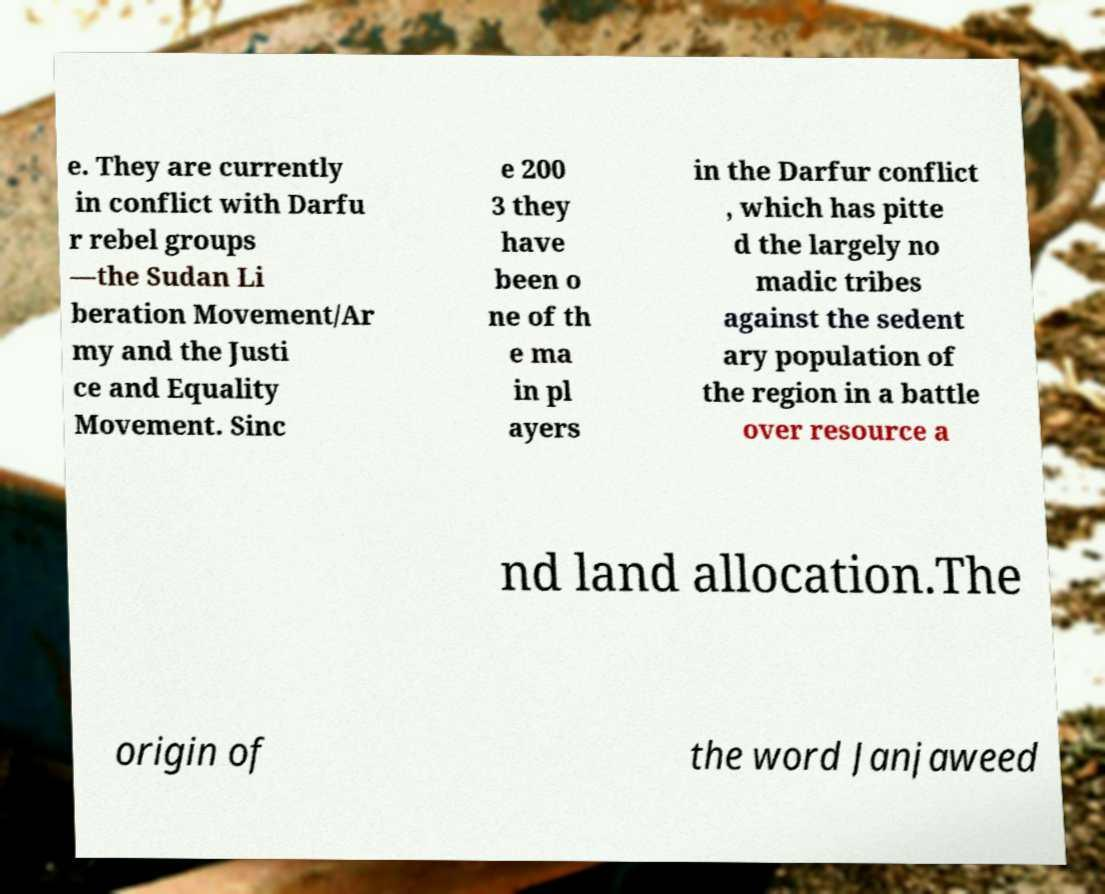For documentation purposes, I need the text within this image transcribed. Could you provide that? e. They are currently in conflict with Darfu r rebel groups —the Sudan Li beration Movement/Ar my and the Justi ce and Equality Movement. Sinc e 200 3 they have been o ne of th e ma in pl ayers in the Darfur conflict , which has pitte d the largely no madic tribes against the sedent ary population of the region in a battle over resource a nd land allocation.The origin of the word Janjaweed 